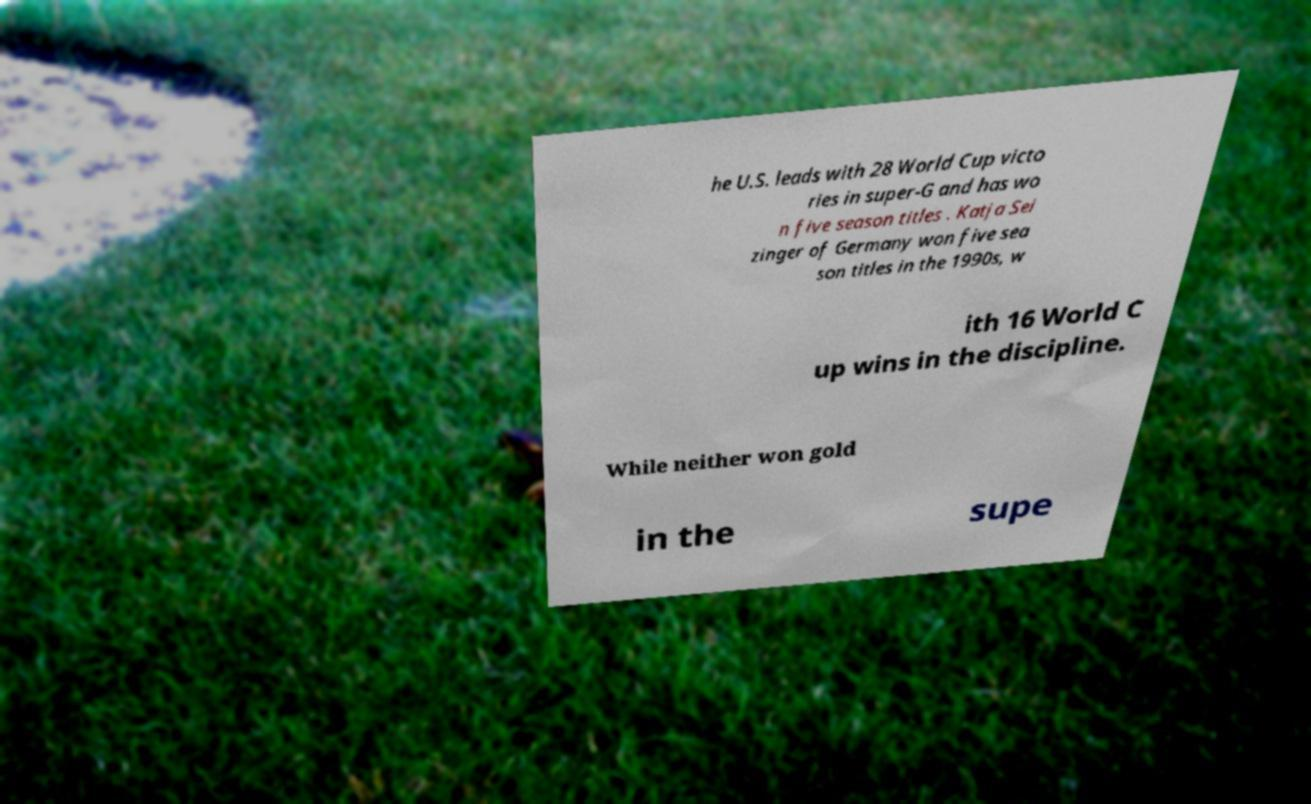Could you assist in decoding the text presented in this image and type it out clearly? he U.S. leads with 28 World Cup victo ries in super-G and has wo n five season titles . Katja Sei zinger of Germany won five sea son titles in the 1990s, w ith 16 World C up wins in the discipline. While neither won gold in the supe 